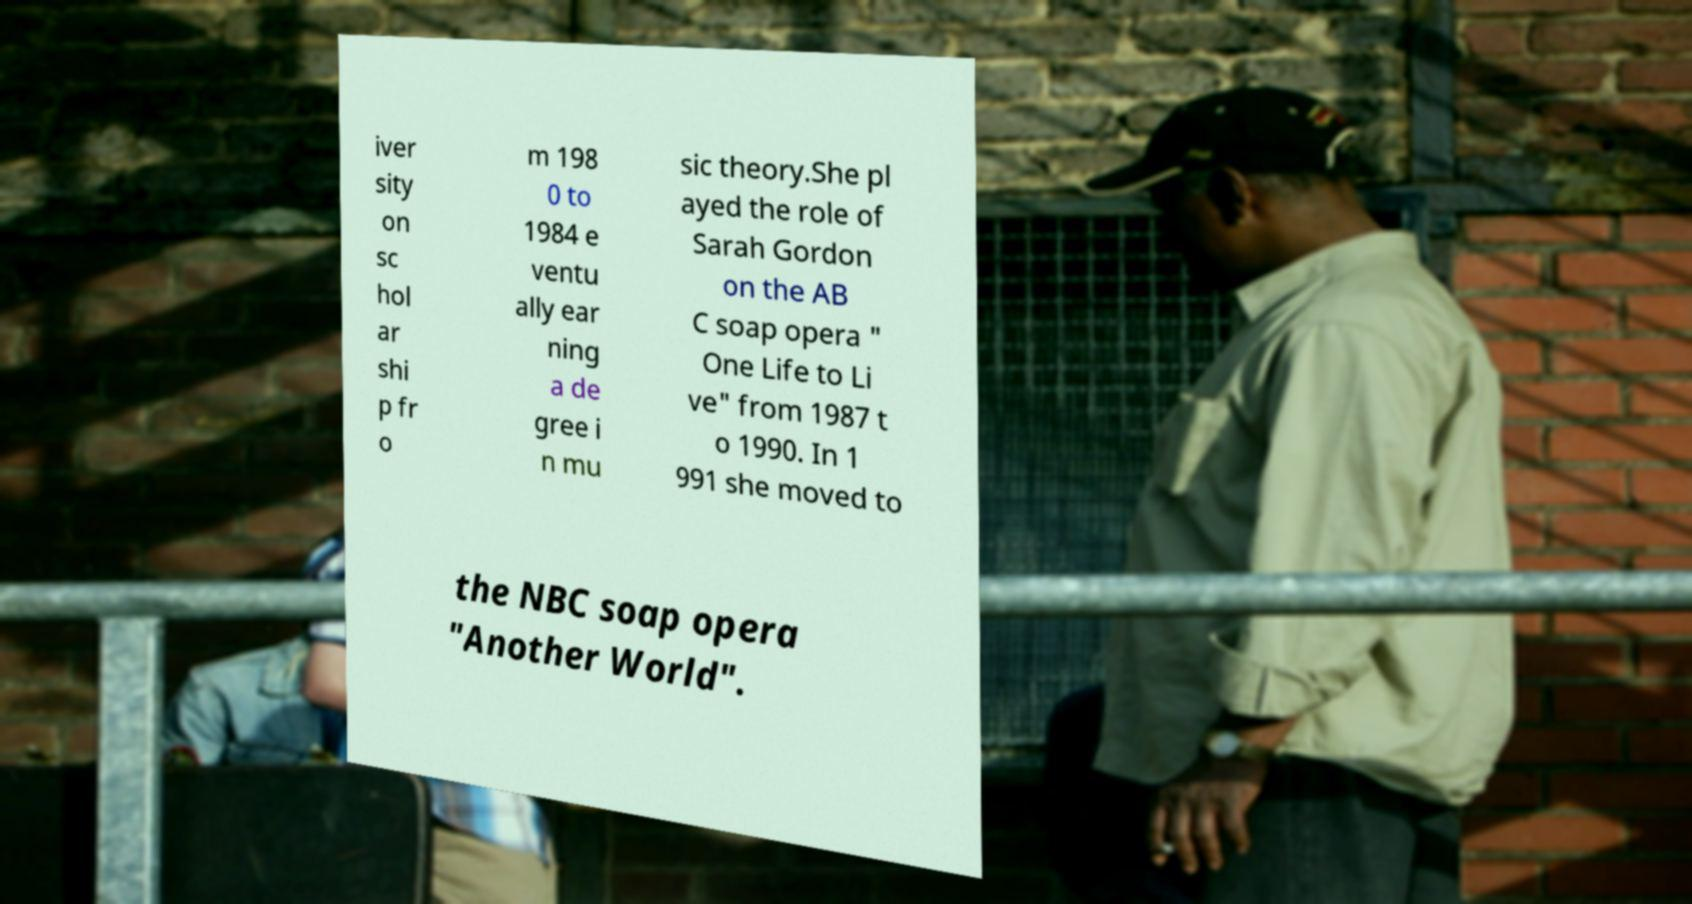Can you accurately transcribe the text from the provided image for me? iver sity on sc hol ar shi p fr o m 198 0 to 1984 e ventu ally ear ning a de gree i n mu sic theory.She pl ayed the role of Sarah Gordon on the AB C soap opera " One Life to Li ve" from 1987 t o 1990. In 1 991 she moved to the NBC soap opera "Another World". 